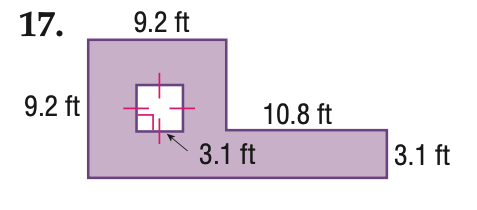Question: Find the area of the shaded region. Round to the nearest tenth if necessary.
Choices:
A. 75.0
B. 108.5
C. 118.1
D. 127.7
Answer with the letter. Answer: B 